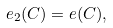<formula> <loc_0><loc_0><loc_500><loc_500>e _ { 2 } ( C ) = e ( C ) ,</formula> 